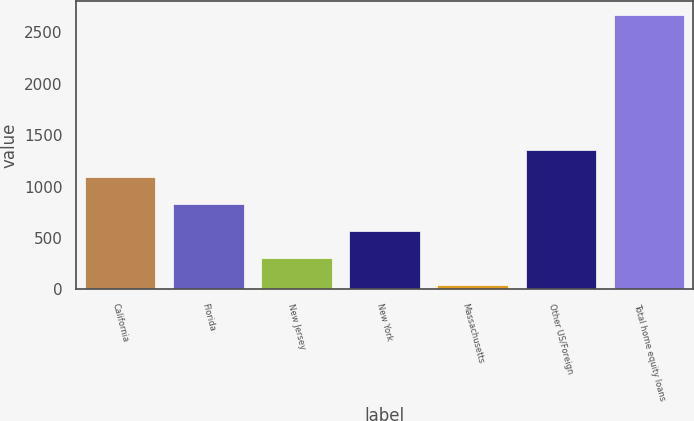Convert chart to OTSL. <chart><loc_0><loc_0><loc_500><loc_500><bar_chart><fcel>California<fcel>Florida<fcel>New Jersey<fcel>New York<fcel>Massachusetts<fcel>Other US/Foreign<fcel>Total home equity loans<nl><fcel>1096.8<fcel>834.6<fcel>310.2<fcel>572.4<fcel>48<fcel>1359<fcel>2670<nl></chart> 